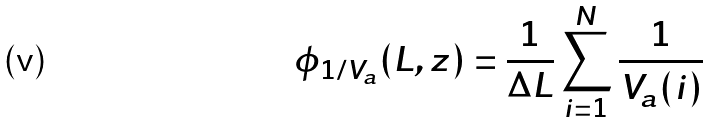<formula> <loc_0><loc_0><loc_500><loc_500>\phi _ { 1 / V _ { a } } ( L , z ) = \frac { 1 } { \Delta L } \sum _ { i = 1 } ^ { N } \frac { 1 } { V _ { a } ( i ) }</formula> 